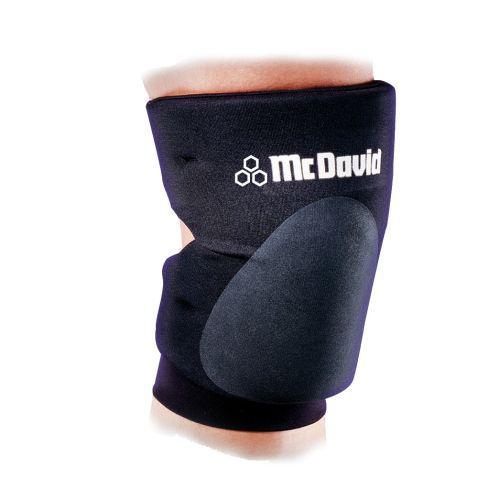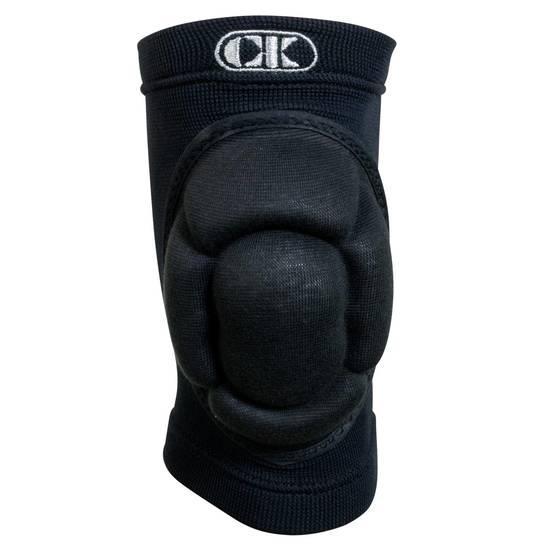The first image is the image on the left, the second image is the image on the right. Examine the images to the left and right. Is the description "The left and right image contains the same number of medium size knee braces." accurate? Answer yes or no. Yes. The first image is the image on the left, the second image is the image on the right. Given the left and right images, does the statement "Each image shows at least one human leg, and at least one image features a long black compression wrap with a knee pad on its front worn on a leg." hold true? Answer yes or no. No. 